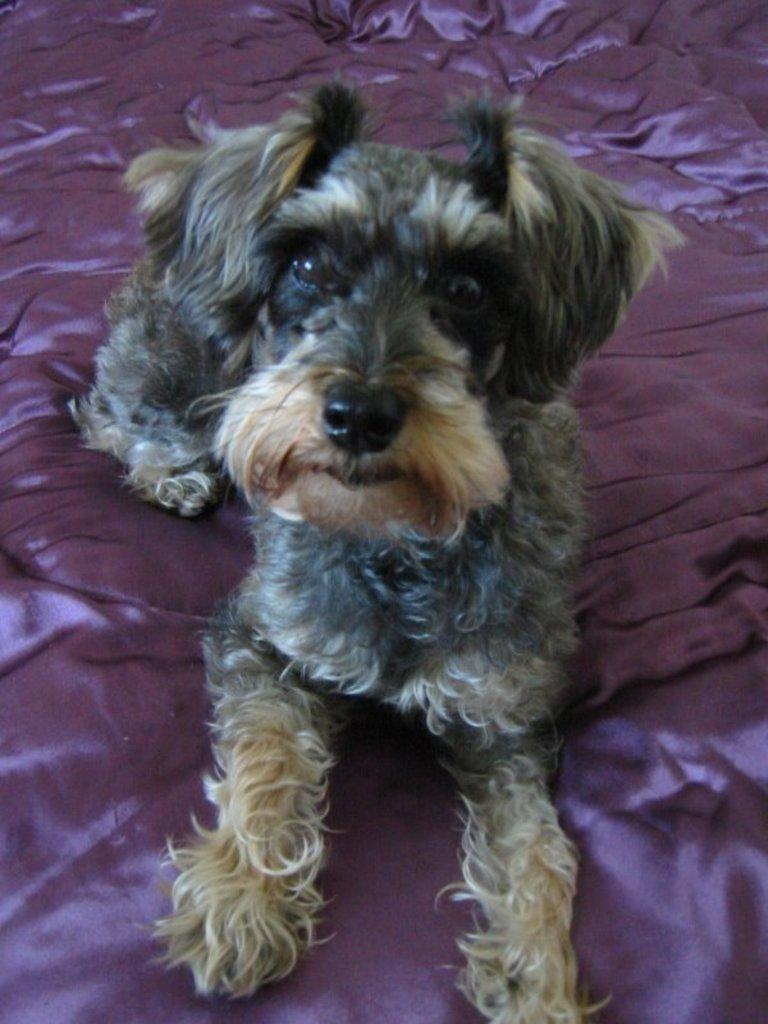What animal is present in the image? There is a dog in the image. What is the dog standing or sitting on? The dog is on a purple surface. What type of tooth can be seen in the dog's mouth in the image? There is no tooth visible in the dog's mouth in the image. Does the dog have a sister in the image? There is no mention of a sister or any other animals in the image, so we cannot determine if the dog has a sister. 